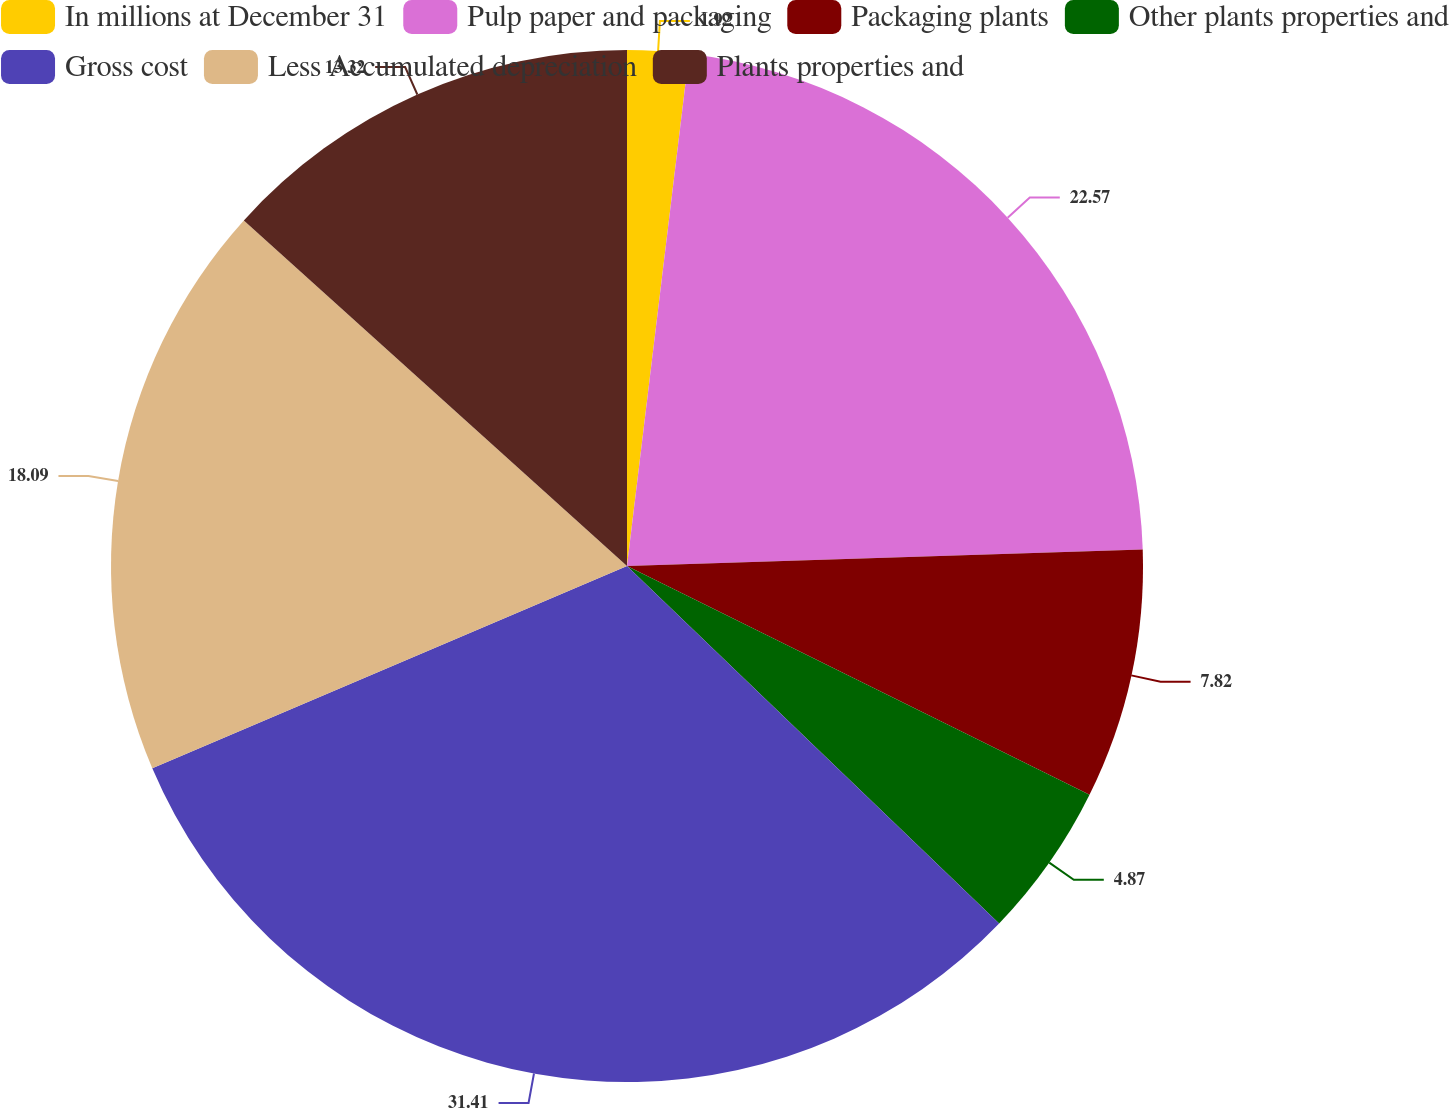Convert chart. <chart><loc_0><loc_0><loc_500><loc_500><pie_chart><fcel>In millions at December 31<fcel>Pulp paper and packaging<fcel>Packaging plants<fcel>Other plants properties and<fcel>Gross cost<fcel>Less Accumulated depreciation<fcel>Plants properties and<nl><fcel>1.92%<fcel>22.57%<fcel>7.82%<fcel>4.87%<fcel>31.41%<fcel>18.09%<fcel>13.32%<nl></chart> 